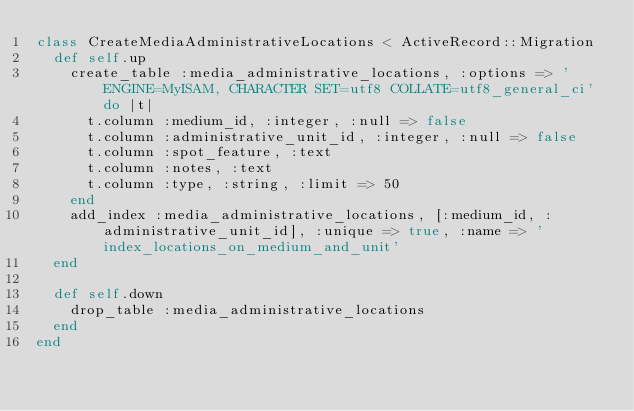<code> <loc_0><loc_0><loc_500><loc_500><_Ruby_>class CreateMediaAdministrativeLocations < ActiveRecord::Migration
  def self.up
    create_table :media_administrative_locations, :options => 'ENGINE=MyISAM, CHARACTER SET=utf8 COLLATE=utf8_general_ci' do |t|
      t.column :medium_id, :integer, :null => false
      t.column :administrative_unit_id, :integer, :null => false
      t.column :spot_feature, :text
      t.column :notes, :text
      t.column :type, :string, :limit => 50
    end
    add_index :media_administrative_locations, [:medium_id, :administrative_unit_id], :unique => true, :name => 'index_locations_on_medium_and_unit'
  end

  def self.down
    drop_table :media_administrative_locations
  end
end
</code> 